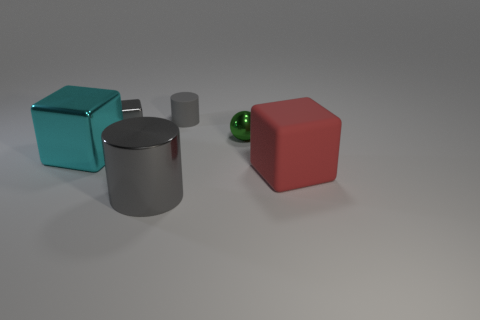Can you describe the colors of the objects in the image? Certainly! There is a teal cube, a silver cylinder, a small grey cylinder, a green sphere, and a red cube. Are there any reflective surfaces visible? The silver cylinder and the green sphere exhibit reflective surfaces, as indicated by the visible highlights and subtle reflections on them. 